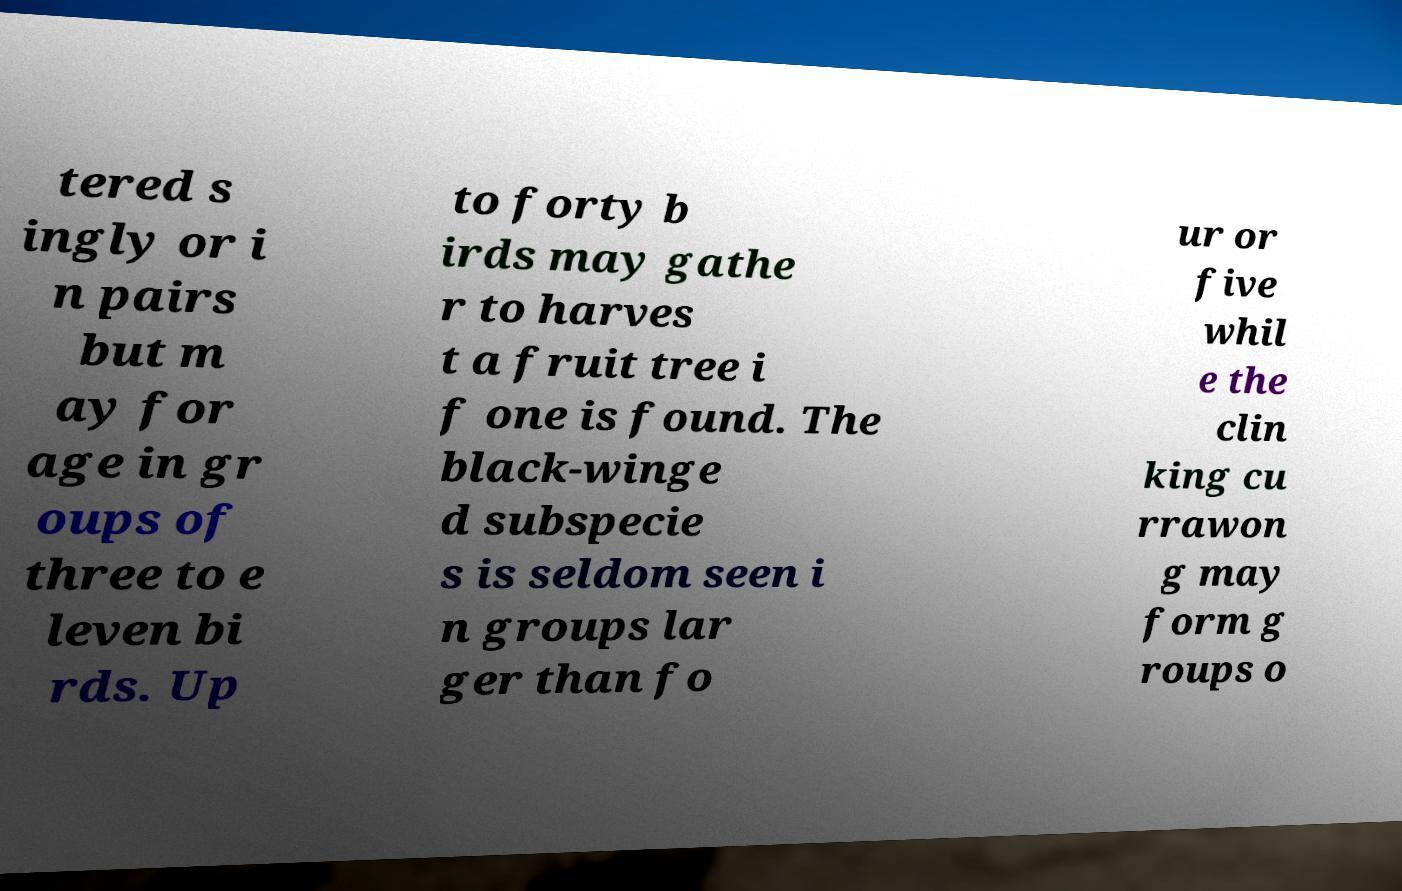What messages or text are displayed in this image? I need them in a readable, typed format. tered s ingly or i n pairs but m ay for age in gr oups of three to e leven bi rds. Up to forty b irds may gathe r to harves t a fruit tree i f one is found. The black-winge d subspecie s is seldom seen i n groups lar ger than fo ur or five whil e the clin king cu rrawon g may form g roups o 